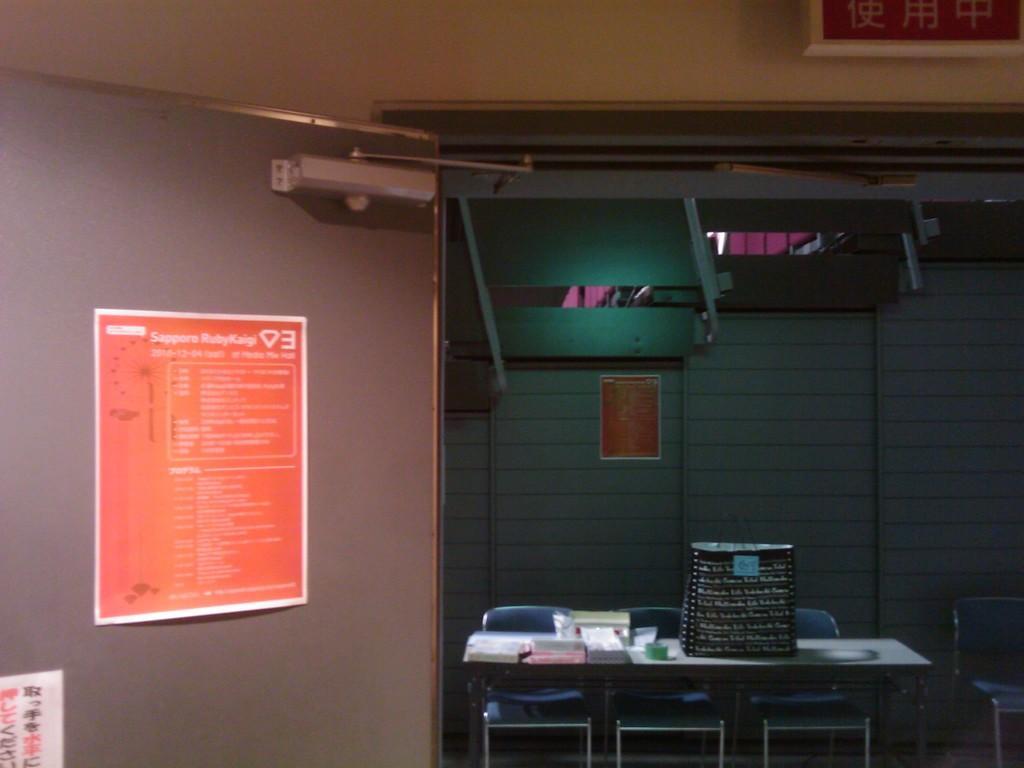How would you summarize this image in a sentence or two? This picture is taken inside the room. In this image, on the left side, we can see a poster which is attached to a wall, on the poster, we can see some text written on it. In the middle of the image, we can see table and chairs, on the table, we can see a carry bag and few books. On the right side, we can also see a chair. In the background, we can see a door. In the background, we can also see a photo frame which is attached to a wall. 